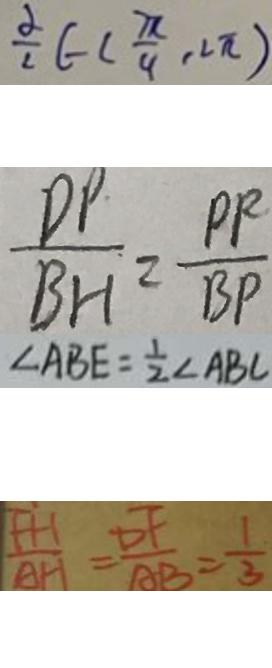<formula> <loc_0><loc_0><loc_500><loc_500>\frac { \alpha } { 2 } \in ( \frac { \pi } { 4 } , 2 \pi ) 
 \frac { D P } { B H } = \frac { P P } { B P } 
 \angle A B E = \frac { 1 } { 2 } \angle A B C 
 \frac { F H } { A H } = \frac { D F } { A B } = \frac { 1 } { 3 }</formula> 